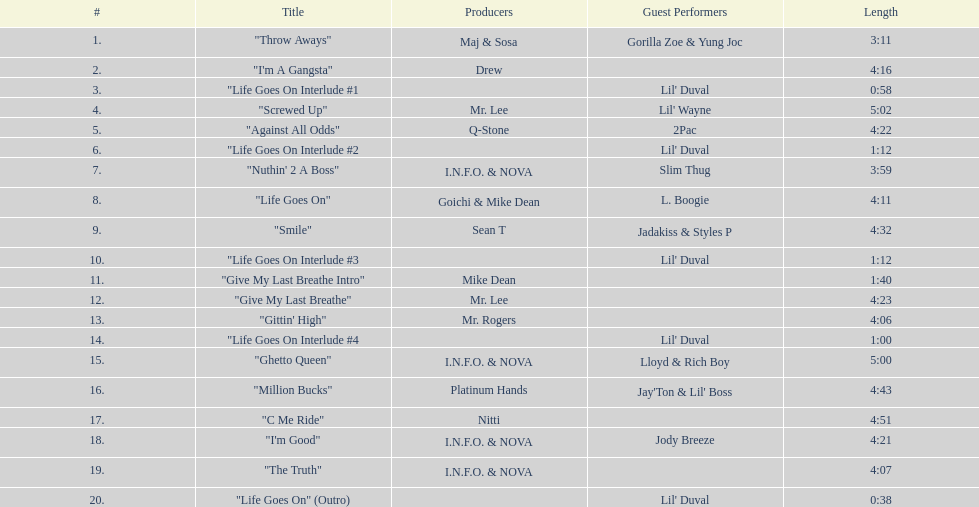What is the premier track with lil' duval? "Life Goes On Interlude #1. 